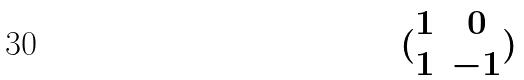<formula> <loc_0><loc_0><loc_500><loc_500>( \begin{matrix} 1 & 0 \\ 1 & - 1 \end{matrix} )</formula> 